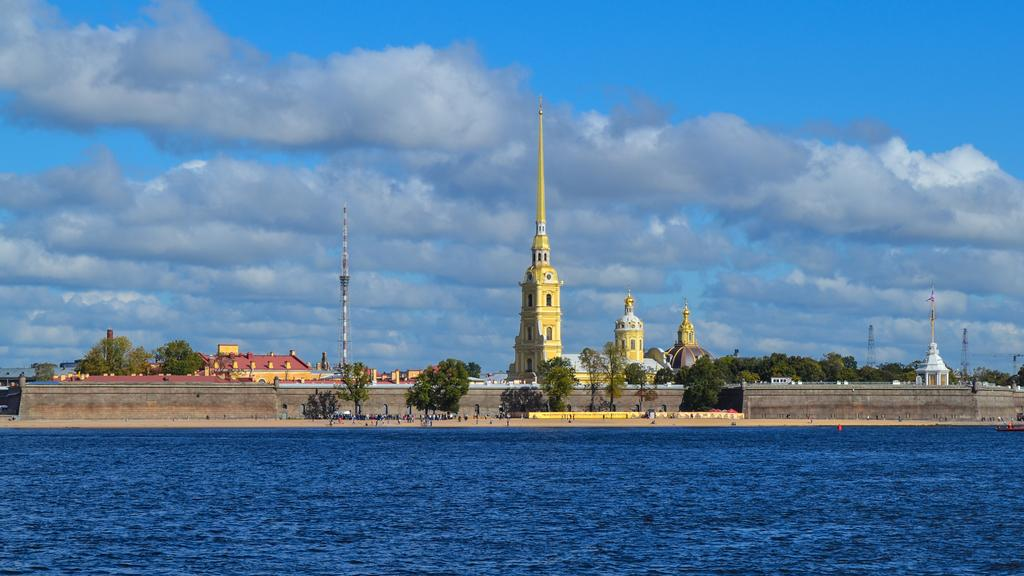What type of natural elements can be seen in the image? There are trees in the image. What type of man-made structures are visible in the image? There are houses and towers in the image. How would you describe the sky in the image? The sky is blue with clouds in the image. What is present at the bottom of the image? Water is present at the bottom of the image. How many pigs are seen playing in the water at the bottom of the image? There are no pigs present in the image; it features trees, houses, towers, and water. Is there a crook visible in the image? There is no crook present in the image. 